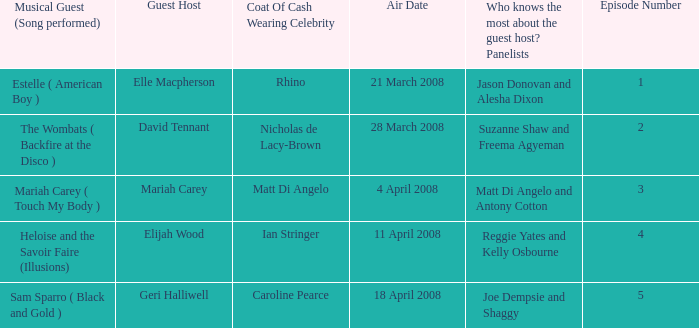Name the musical guest where guest host is elle macpherson Estelle ( American Boy ). 